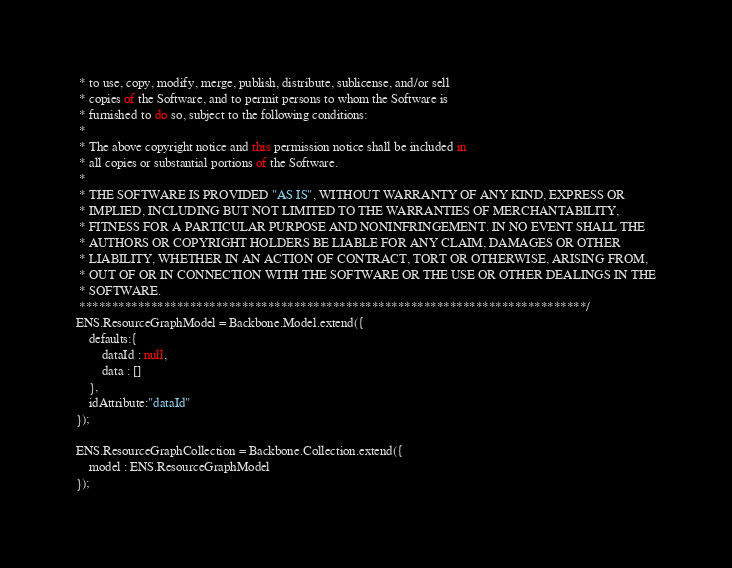<code> <loc_0><loc_0><loc_500><loc_500><_JavaScript_> * to use, copy, modify, merge, publish, distribute, sublicense, and/or sell
 * copies of the Software, and to permit persons to whom the Software is
 * furnished to do so, subject to the following conditions:
 * 
 * The above copyright notice and this permission notice shall be included in
 * all copies or substantial portions of the Software.
 * 
 * THE SOFTWARE IS PROVIDED "AS IS", WITHOUT WARRANTY OF ANY KIND, EXPRESS OR
 * IMPLIED, INCLUDING BUT NOT LIMITED TO THE WARRANTIES OF MERCHANTABILITY,
 * FITNESS FOR A PARTICULAR PURPOSE AND NONINFRINGEMENT. IN NO EVENT SHALL THE
 * AUTHORS OR COPYRIGHT HOLDERS BE LIABLE FOR ANY CLAIM, DAMAGES OR OTHER
 * LIABILITY, WHETHER IN AN ACTION OF CONTRACT, TORT OR OTHERWISE, ARISING FROM,
 * OUT OF OR IN CONNECTION WITH THE SOFTWARE OR THE USE OR OTHER DEALINGS IN THE
 * SOFTWARE.
 ******************************************************************************/
ENS.ResourceGraphModel = Backbone.Model.extend({
	defaults:{
		dataId : null,
		data : []
	},
	idAttribute:"dataId"
});

ENS.ResourceGraphCollection = Backbone.Collection.extend({
	model : ENS.ResourceGraphModel
});</code> 